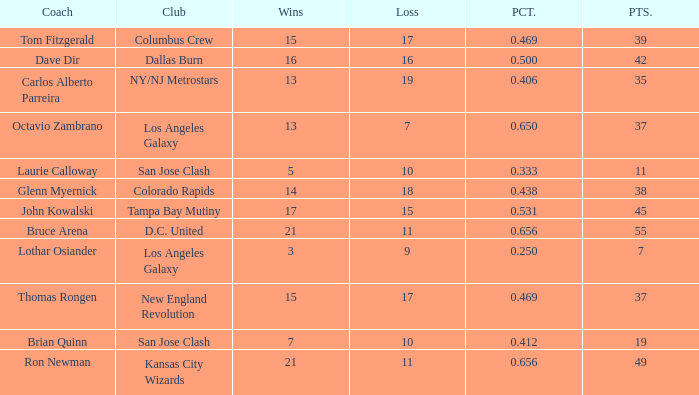What is the highest percent of Bruce Arena when he loses more than 11 games? None. 